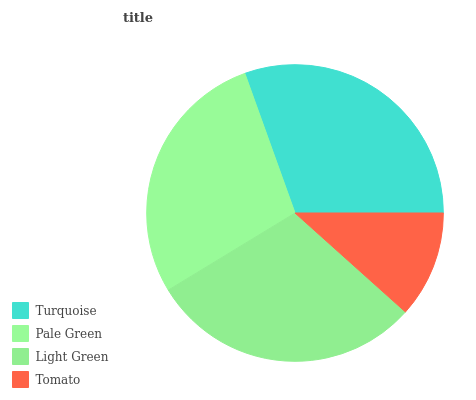Is Tomato the minimum?
Answer yes or no. Yes. Is Turquoise the maximum?
Answer yes or no. Yes. Is Pale Green the minimum?
Answer yes or no. No. Is Pale Green the maximum?
Answer yes or no. No. Is Turquoise greater than Pale Green?
Answer yes or no. Yes. Is Pale Green less than Turquoise?
Answer yes or no. Yes. Is Pale Green greater than Turquoise?
Answer yes or no. No. Is Turquoise less than Pale Green?
Answer yes or no. No. Is Light Green the high median?
Answer yes or no. Yes. Is Pale Green the low median?
Answer yes or no. Yes. Is Tomato the high median?
Answer yes or no. No. Is Turquoise the low median?
Answer yes or no. No. 